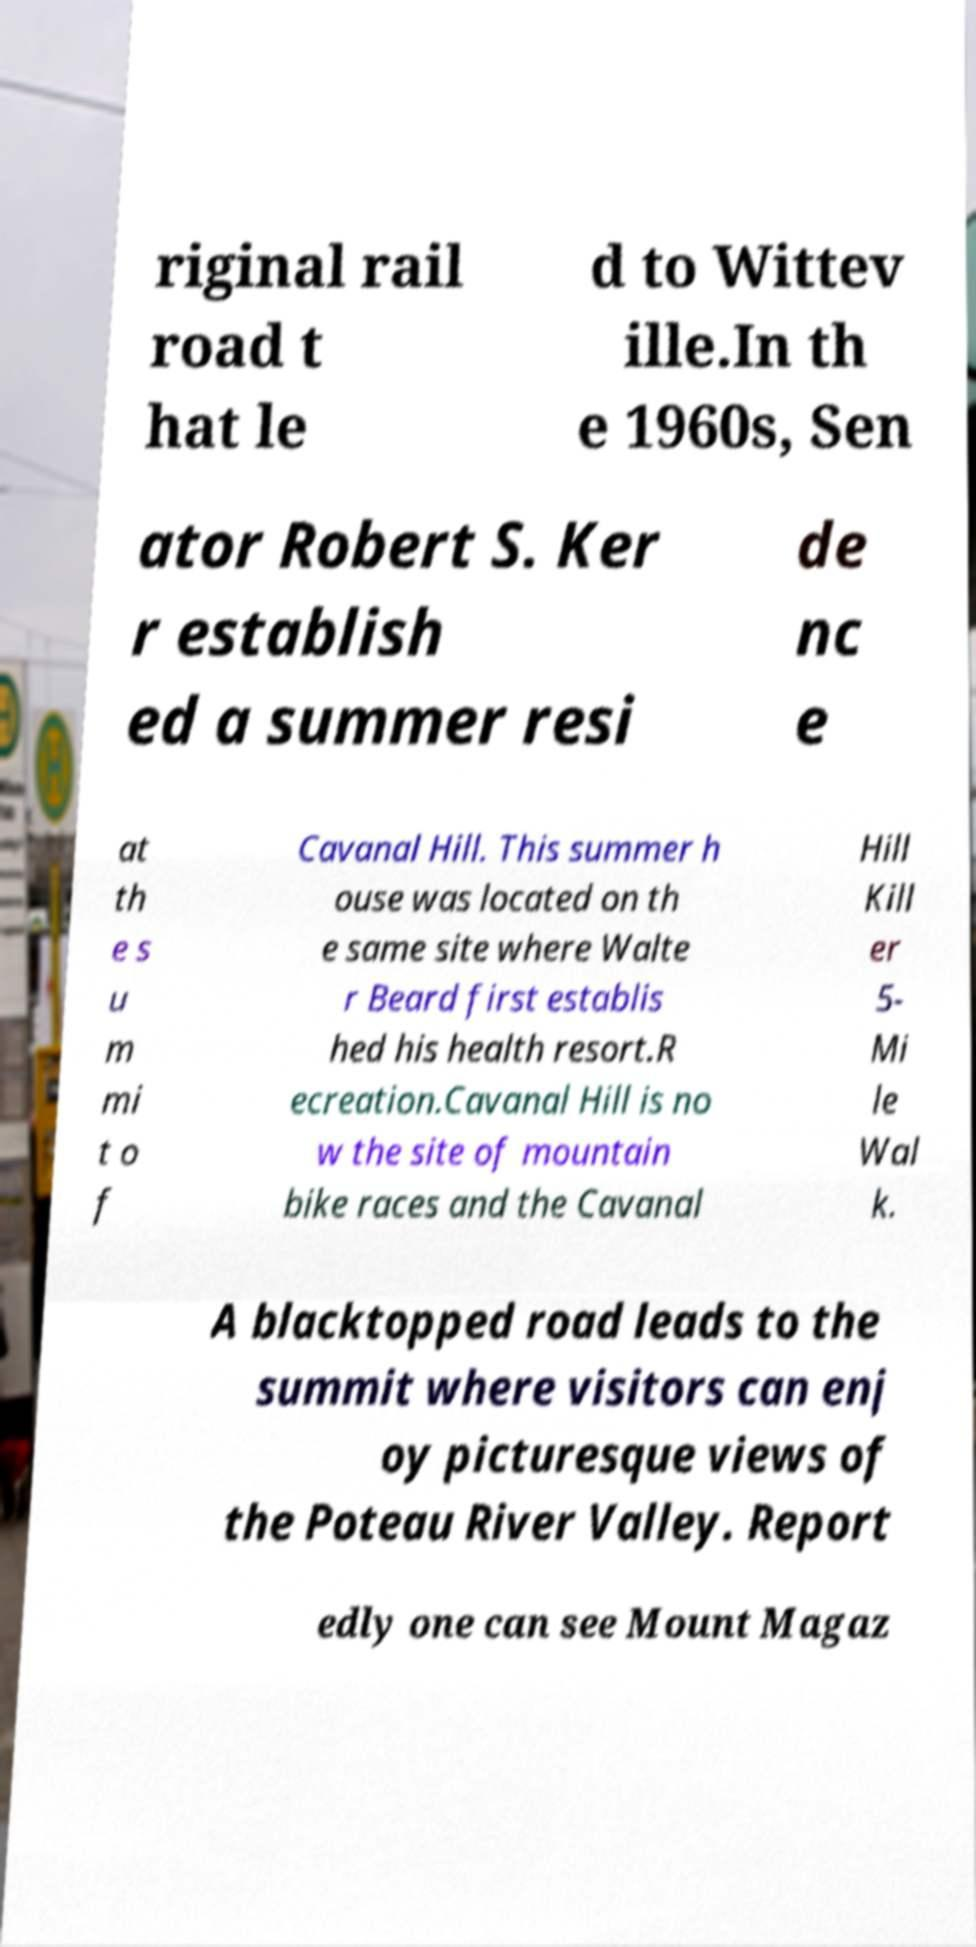Can you read and provide the text displayed in the image?This photo seems to have some interesting text. Can you extract and type it out for me? riginal rail road t hat le d to Wittev ille.In th e 1960s, Sen ator Robert S. Ker r establish ed a summer resi de nc e at th e s u m mi t o f Cavanal Hill. This summer h ouse was located on th e same site where Walte r Beard first establis hed his health resort.R ecreation.Cavanal Hill is no w the site of mountain bike races and the Cavanal Hill Kill er 5- Mi le Wal k. A blacktopped road leads to the summit where visitors can enj oy picturesque views of the Poteau River Valley. Report edly one can see Mount Magaz 